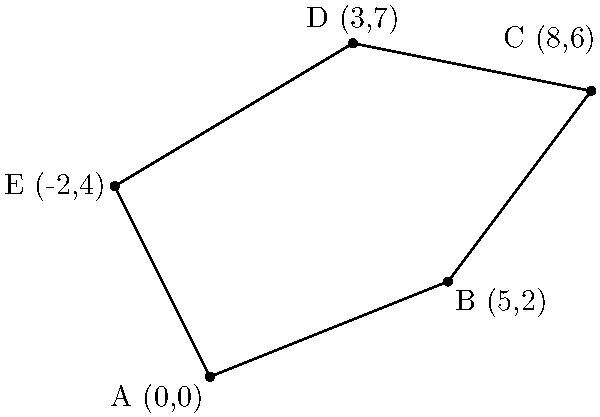You're planning to set up your produce stand at a new farmers' market. The market area is irregularly shaped, and you need to calculate the perimeter to estimate the space available for vendors. Given the coordinates of the market's corners: A(0,0), B(5,2), C(8,6), D(3,7), and E(-2,4), what is the perimeter of the farmers' market area? To find the perimeter, we need to calculate the distance between each consecutive pair of points and sum them up. We'll use the distance formula: $d = \sqrt{(x_2-x_1)^2 + (y_2-y_1)^2}$

1. Distance AB: $\sqrt{(5-0)^2 + (2-0)^2} = \sqrt{25 + 4} = \sqrt{29}$

2. Distance BC: $\sqrt{(8-5)^2 + (6-2)^2} = \sqrt{9 + 16} = 5$

3. Distance CD: $\sqrt{(3-8)^2 + (7-6)^2} = \sqrt{25 + 1} = \sqrt{26}$

4. Distance DE: $\sqrt{(-2-3)^2 + (4-7)^2} = \sqrt{25 + 9} = \sqrt{34}$

5. Distance EA: $\sqrt{(0-(-2))^2 + (0-4)^2} = \sqrt{4 + 16} = \sqrt{20}$

Now, sum all these distances:

Perimeter = $\sqrt{29} + 5 + \sqrt{26} + \sqrt{34} + \sqrt{20}$

Simplifying: $5 + \sqrt{29} + \sqrt{26} + \sqrt{34} + \sqrt{20}$ units
Answer: $5 + \sqrt{29} + \sqrt{26} + \sqrt{34} + \sqrt{20}$ units 